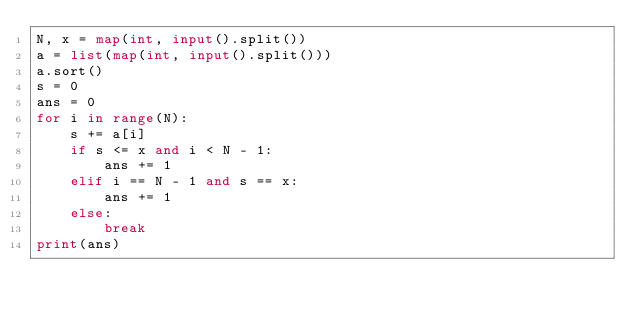Convert code to text. <code><loc_0><loc_0><loc_500><loc_500><_Python_>N, x = map(int, input().split())
a = list(map(int, input().split()))
a.sort()
s = 0
ans = 0
for i in range(N):
    s += a[i]
    if s <= x and i < N - 1:
        ans += 1
    elif i == N - 1 and s == x:
        ans += 1
    else:
        break
print(ans)</code> 